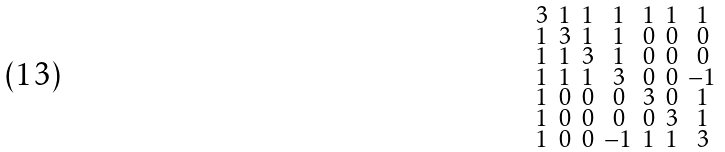Convert formula to latex. <formula><loc_0><loc_0><loc_500><loc_500>\begin{smallmatrix} 3 & 1 & 1 & 1 & 1 & 1 & 1 \\ 1 & 3 & 1 & 1 & 0 & 0 & 0 \\ 1 & 1 & 3 & 1 & 0 & 0 & 0 \\ 1 & 1 & 1 & 3 & 0 & 0 & - 1 \\ 1 & 0 & 0 & 0 & 3 & 0 & 1 \\ 1 & 0 & 0 & 0 & 0 & 3 & 1 \\ 1 & 0 & 0 & - 1 & 1 & 1 & 3 \end{smallmatrix}</formula> 